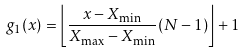<formula> <loc_0><loc_0><loc_500><loc_500>g _ { 1 } ( x ) = \left \lfloor { \frac { x - X _ { \min } } { X _ { \max } - X _ { \min } } ( N - 1 ) } \right \rfloor + 1</formula> 